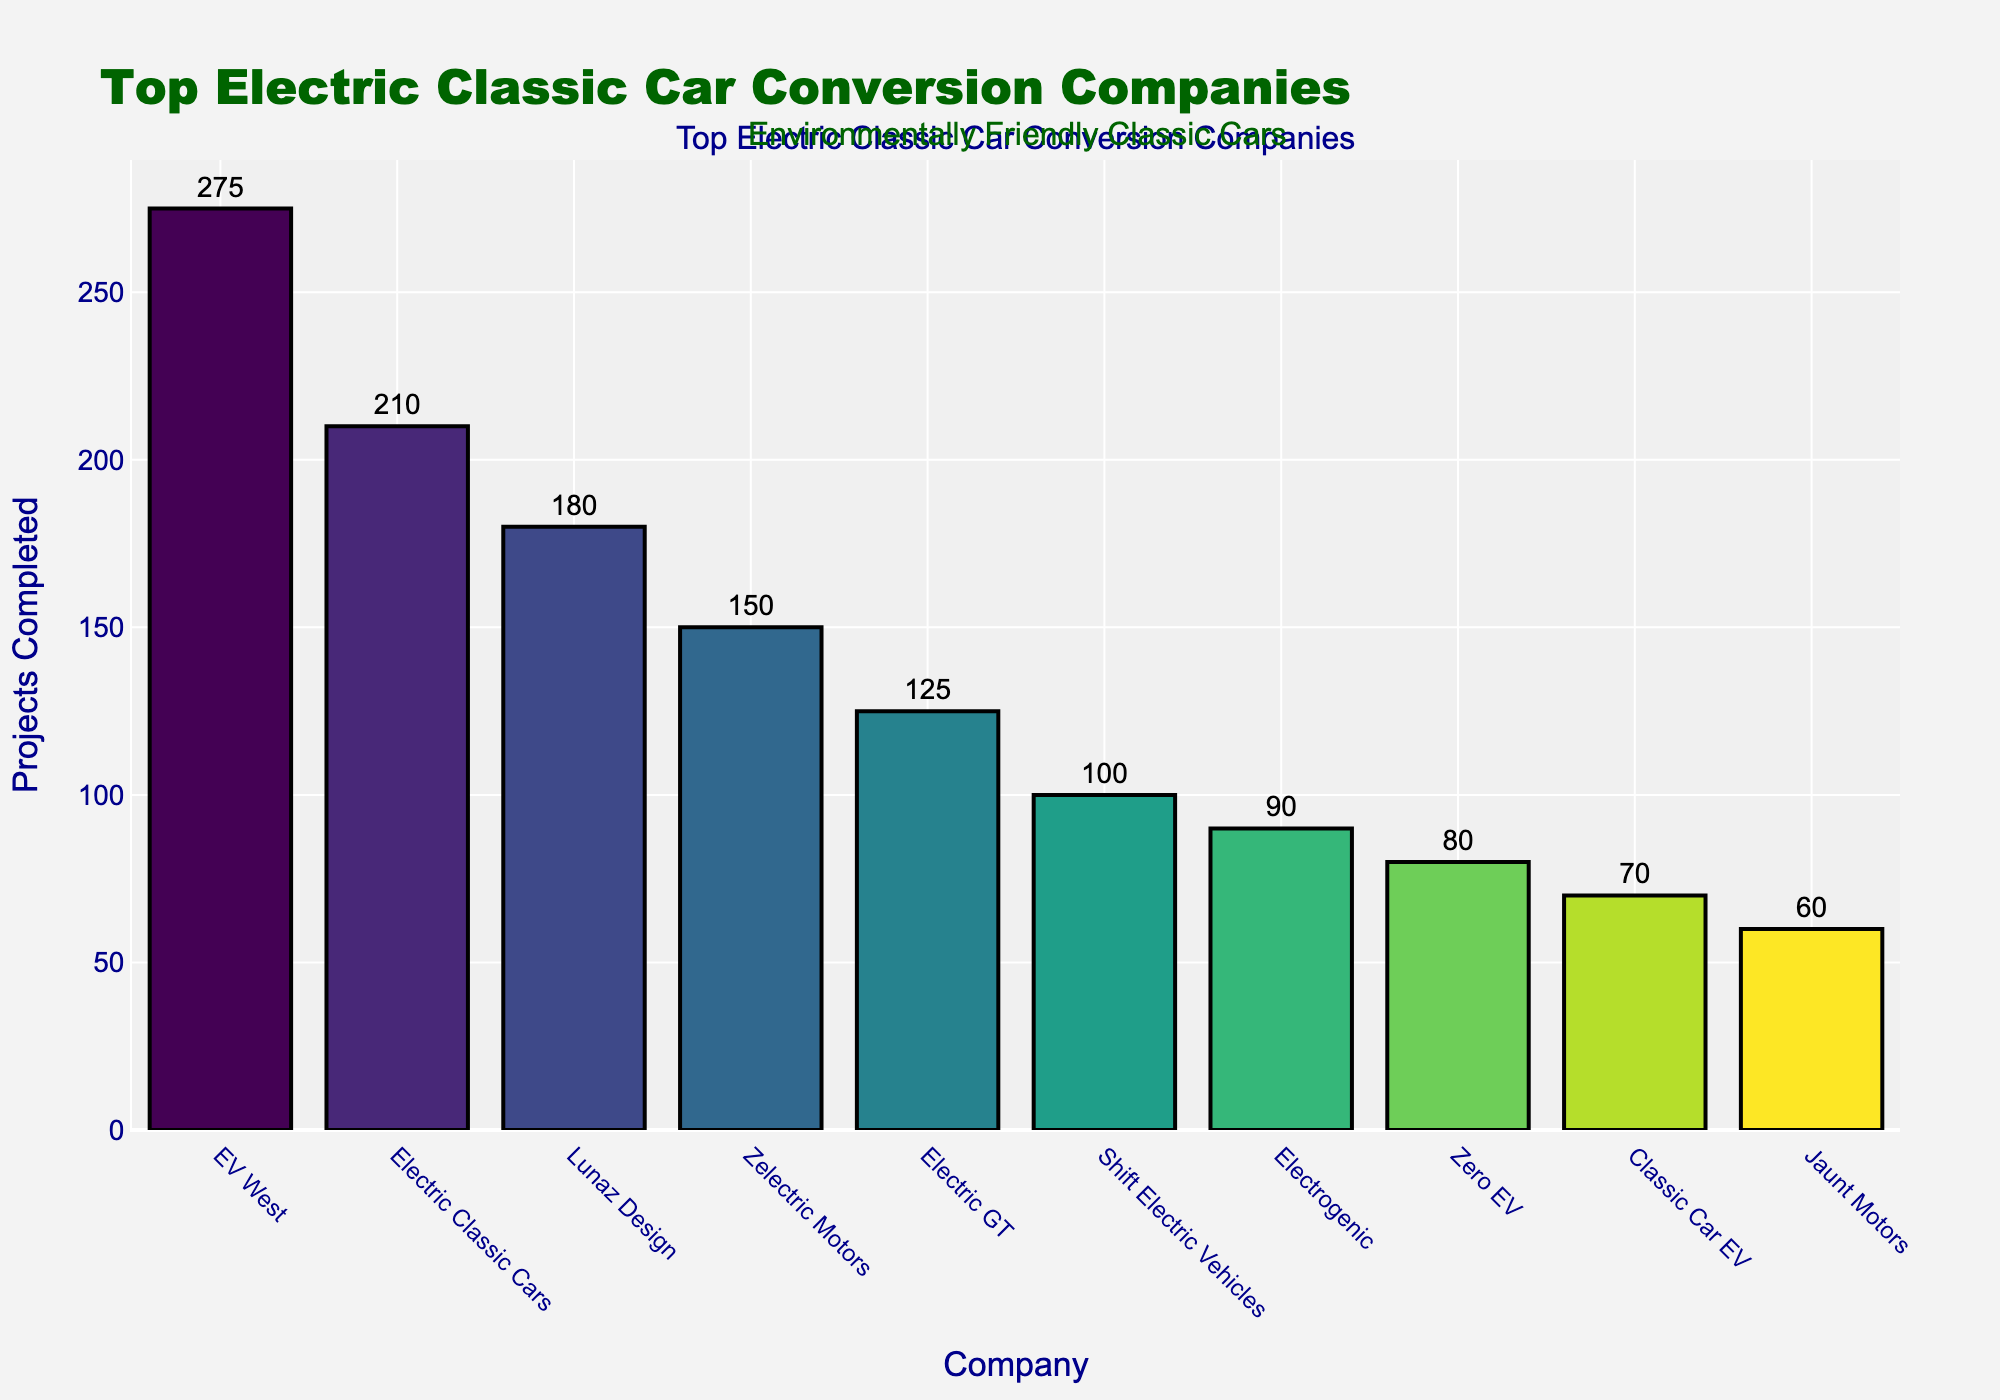what company completed the most projects? The company with the highest bar has completed the most projects. In this case, it is EV West.
Answer: EV West how many more projects did Electric Classic Cars complete than Electric GT? Subtract the number of projects completed by Electric GT from the number completed by Electric Classic Cars (210 - 125).
Answer: 85 which company completed the third-most projects? Look for the company with the third-highest bar. Lunaz Design comes after EV West and Electric Classic Cars in the descending order.
Answer: Lunaz Design what is the total number of projects completed by EV West and Zelectric Motors? Sum the number of projects completed by EV West and Zelectric Motors (275 + 150).
Answer: 425 what is the average number of projects completed by the top five companies? Sum the projects completed by the top five companies and divide by 5 (275 + 210 + 180 + 150 + 125) / 5.
Answer: 188 which company is in the middle of the top five in terms of the number of projects completed? Since there are five companies, the middle one is the third company in the sorted list. This is Lunaz Design.
Answer: Lunaz Design how many more projects did EV West complete than the company with the fifth highest number of projects? Subtract the number of projects completed by the company with the fifth highest number (Electric GT) from EV West’s total (275 - 125).
Answer: 150 how many total projects were completed by the companies ranked fourth and fifth? Add the projects completed by Zelectric Motors and Electric GT (150 + 125).
Answer: 275 which company has the second shortest bar? The second shortest bar indicates the second-lowest number of projects. This is Electrogenic.
Answer: Electrogenic which bar is the tallest and what does it signify? The tallest bar represents the company with the most projects, which is EV West.
Answer: EV West, most projects 